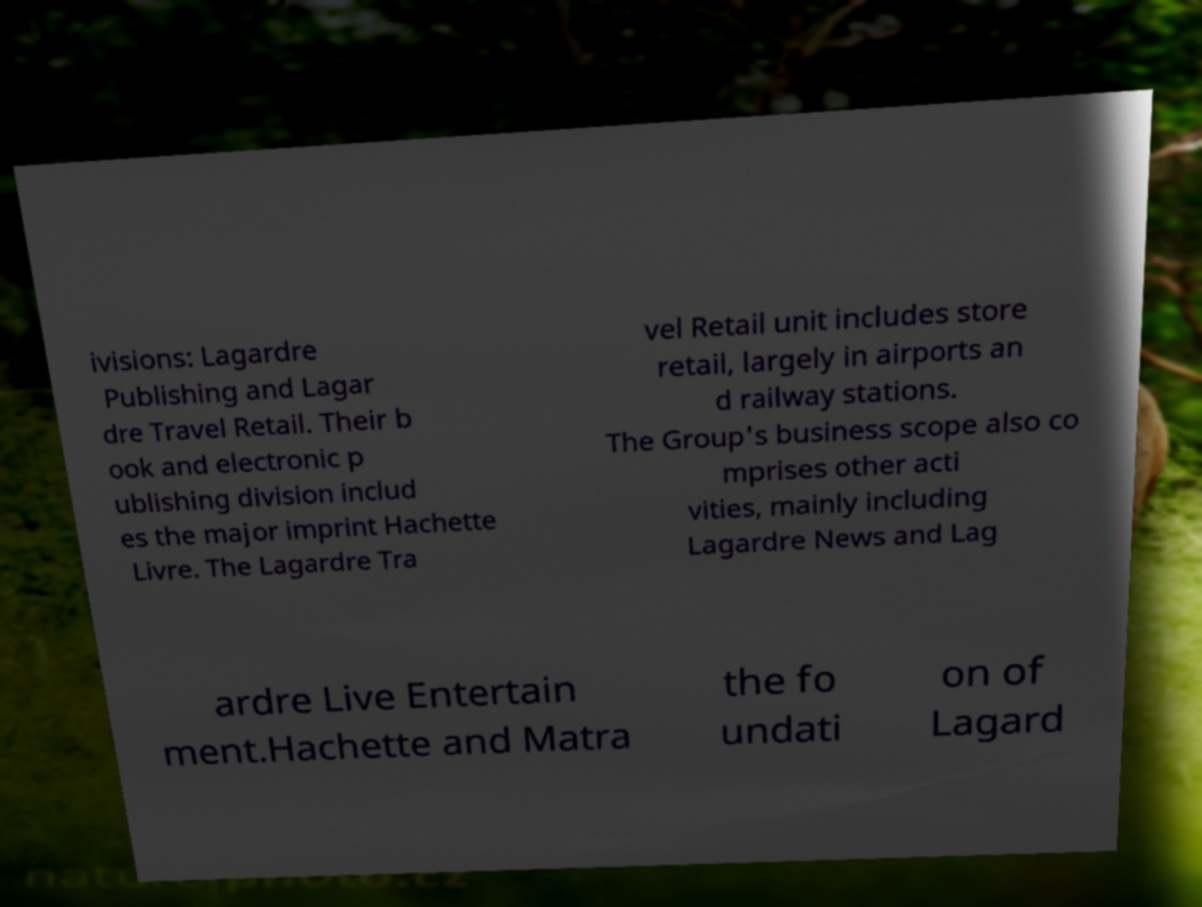What messages or text are displayed in this image? I need them in a readable, typed format. ivisions: Lagardre Publishing and Lagar dre Travel Retail. Their b ook and electronic p ublishing division includ es the major imprint Hachette Livre. The Lagardre Tra vel Retail unit includes store retail, largely in airports an d railway stations. The Group's business scope also co mprises other acti vities, mainly including Lagardre News and Lag ardre Live Entertain ment.Hachette and Matra the fo undati on of Lagard 